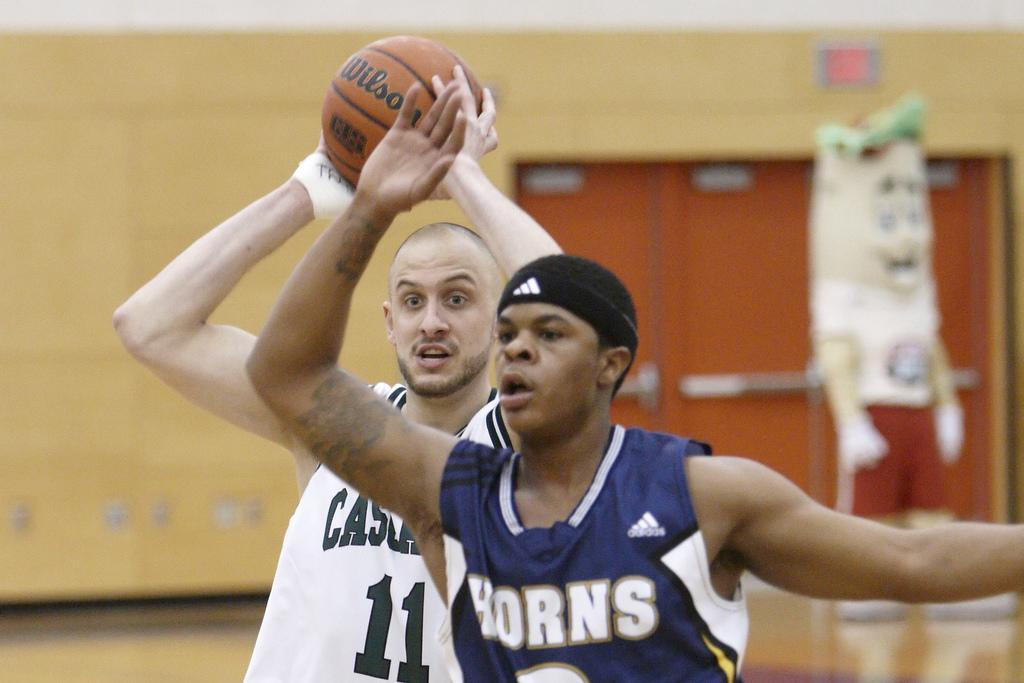What is the person in the white dress holding in the image? The person is holding a ball in their hands. Can you describe the other person in the image? The other person is wearing a blue dress. What else can be seen in the background of the image? There are other objects in the background of the image. What type of account is the person in the white dress opening in the image? There is no mention of an account in the image, as it features a person holding a ball and another person wearing a blue dress. Can you see any blood on the person in the blue dress in the image? There is no blood visible on the person in the blue dress in the image. 